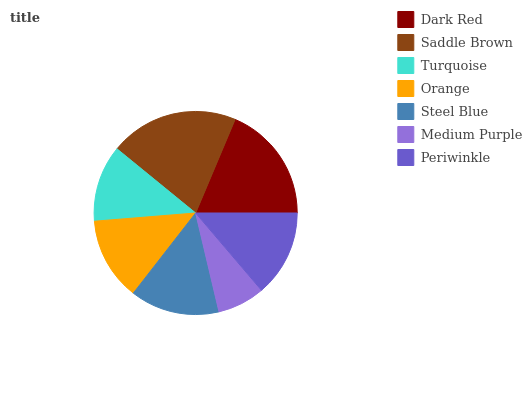Is Medium Purple the minimum?
Answer yes or no. Yes. Is Saddle Brown the maximum?
Answer yes or no. Yes. Is Turquoise the minimum?
Answer yes or no. No. Is Turquoise the maximum?
Answer yes or no. No. Is Saddle Brown greater than Turquoise?
Answer yes or no. Yes. Is Turquoise less than Saddle Brown?
Answer yes or no. Yes. Is Turquoise greater than Saddle Brown?
Answer yes or no. No. Is Saddle Brown less than Turquoise?
Answer yes or no. No. Is Periwinkle the high median?
Answer yes or no. Yes. Is Periwinkle the low median?
Answer yes or no. Yes. Is Saddle Brown the high median?
Answer yes or no. No. Is Medium Purple the low median?
Answer yes or no. No. 